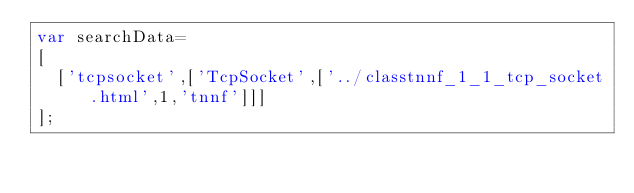Convert code to text. <code><loc_0><loc_0><loc_500><loc_500><_JavaScript_>var searchData=
[
  ['tcpsocket',['TcpSocket',['../classtnnf_1_1_tcp_socket.html',1,'tnnf']]]
];
</code> 